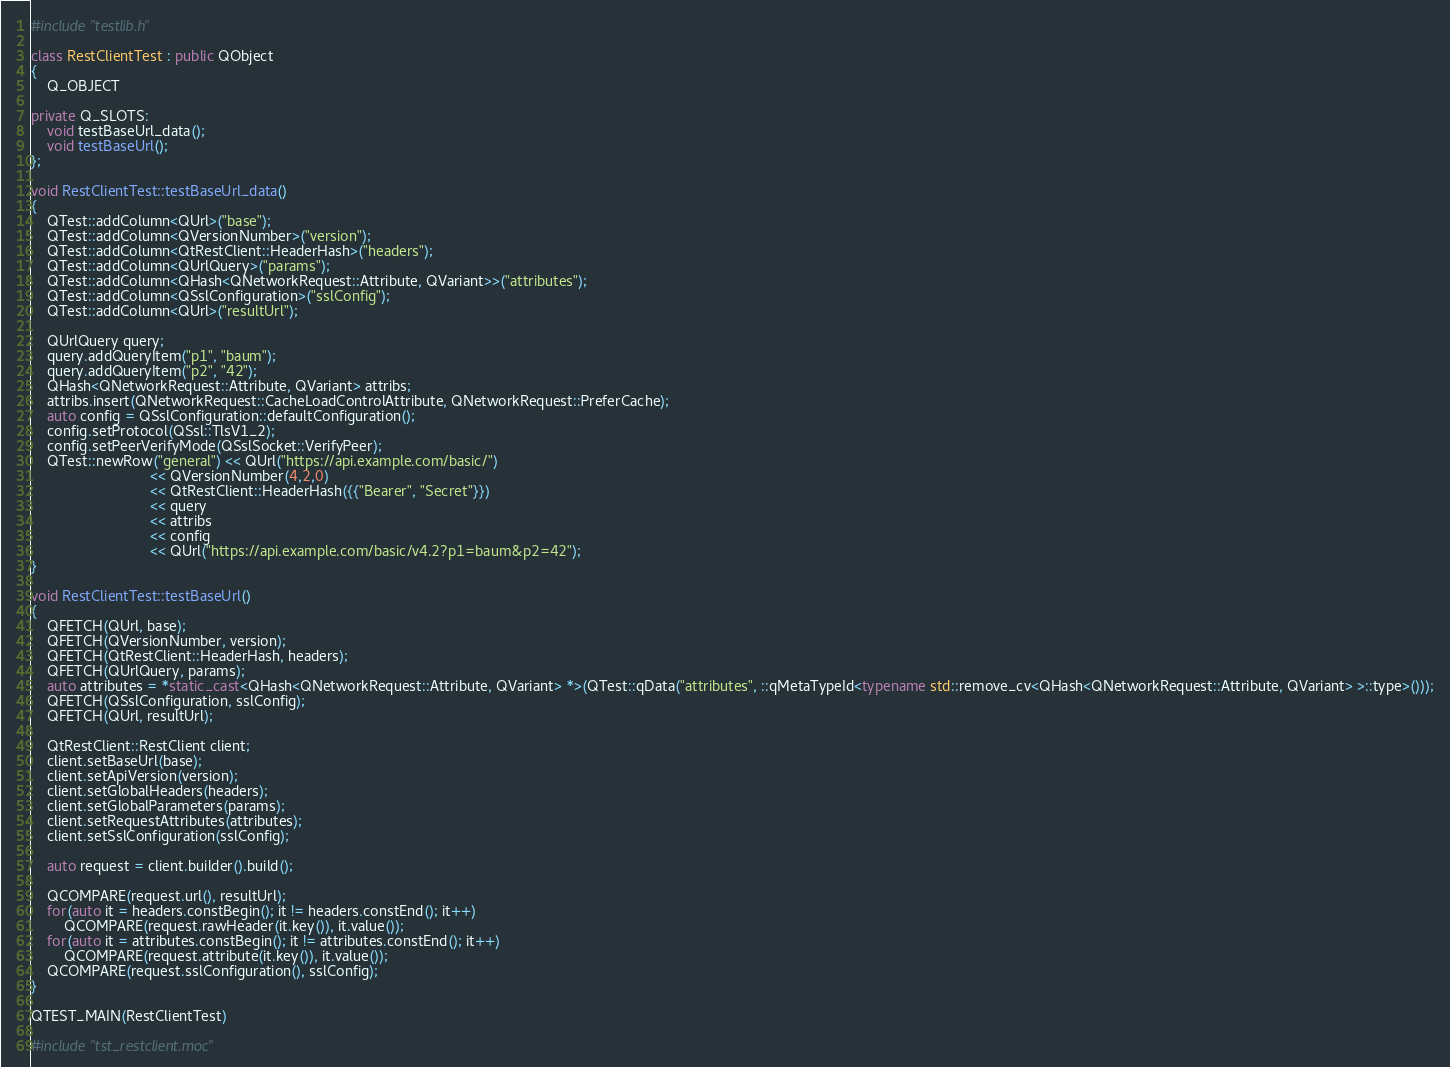Convert code to text. <code><loc_0><loc_0><loc_500><loc_500><_C++_>#include "testlib.h"

class RestClientTest : public QObject
{
	Q_OBJECT

private Q_SLOTS:
	void testBaseUrl_data();
	void testBaseUrl();
};

void RestClientTest::testBaseUrl_data()
{
	QTest::addColumn<QUrl>("base");
	QTest::addColumn<QVersionNumber>("version");
	QTest::addColumn<QtRestClient::HeaderHash>("headers");
	QTest::addColumn<QUrlQuery>("params");
	QTest::addColumn<QHash<QNetworkRequest::Attribute, QVariant>>("attributes");
	QTest::addColumn<QSslConfiguration>("sslConfig");
	QTest::addColumn<QUrl>("resultUrl");

	QUrlQuery query;
	query.addQueryItem("p1", "baum");
	query.addQueryItem("p2", "42");
	QHash<QNetworkRequest::Attribute, QVariant> attribs;
	attribs.insert(QNetworkRequest::CacheLoadControlAttribute, QNetworkRequest::PreferCache);
	auto config = QSslConfiguration::defaultConfiguration();
	config.setProtocol(QSsl::TlsV1_2);
	config.setPeerVerifyMode(QSslSocket::VerifyPeer);
	QTest::newRow("general") << QUrl("https://api.example.com/basic/")
							 << QVersionNumber(4,2,0)
							 << QtRestClient::HeaderHash({{"Bearer", "Secret"}})
							 << query
							 << attribs
							 << config
							 << QUrl("https://api.example.com/basic/v4.2?p1=baum&p2=42");
}

void RestClientTest::testBaseUrl()
{
	QFETCH(QUrl, base);
	QFETCH(QVersionNumber, version);
	QFETCH(QtRestClient::HeaderHash, headers);
	QFETCH(QUrlQuery, params);
	auto attributes = *static_cast<QHash<QNetworkRequest::Attribute, QVariant> *>(QTest::qData("attributes", ::qMetaTypeId<typename std::remove_cv<QHash<QNetworkRequest::Attribute, QVariant> >::type>()));
	QFETCH(QSslConfiguration, sslConfig);
	QFETCH(QUrl, resultUrl);

	QtRestClient::RestClient client;
	client.setBaseUrl(base);
	client.setApiVersion(version);
	client.setGlobalHeaders(headers);
	client.setGlobalParameters(params);
	client.setRequestAttributes(attributes);
	client.setSslConfiguration(sslConfig);

	auto request = client.builder().build();

	QCOMPARE(request.url(), resultUrl);
	for(auto it = headers.constBegin(); it != headers.constEnd(); it++)
		QCOMPARE(request.rawHeader(it.key()), it.value());
	for(auto it = attributes.constBegin(); it != attributes.constEnd(); it++)
		QCOMPARE(request.attribute(it.key()), it.value());
	QCOMPARE(request.sslConfiguration(), sslConfig);
}

QTEST_MAIN(RestClientTest)

#include "tst_restclient.moc"
</code> 